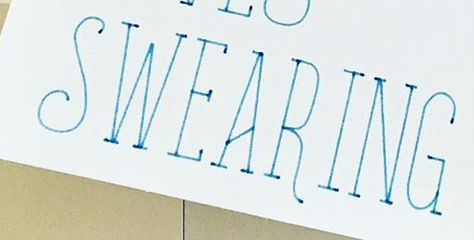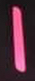Read the text from these images in sequence, separated by a semicolon. SWEARING; I 